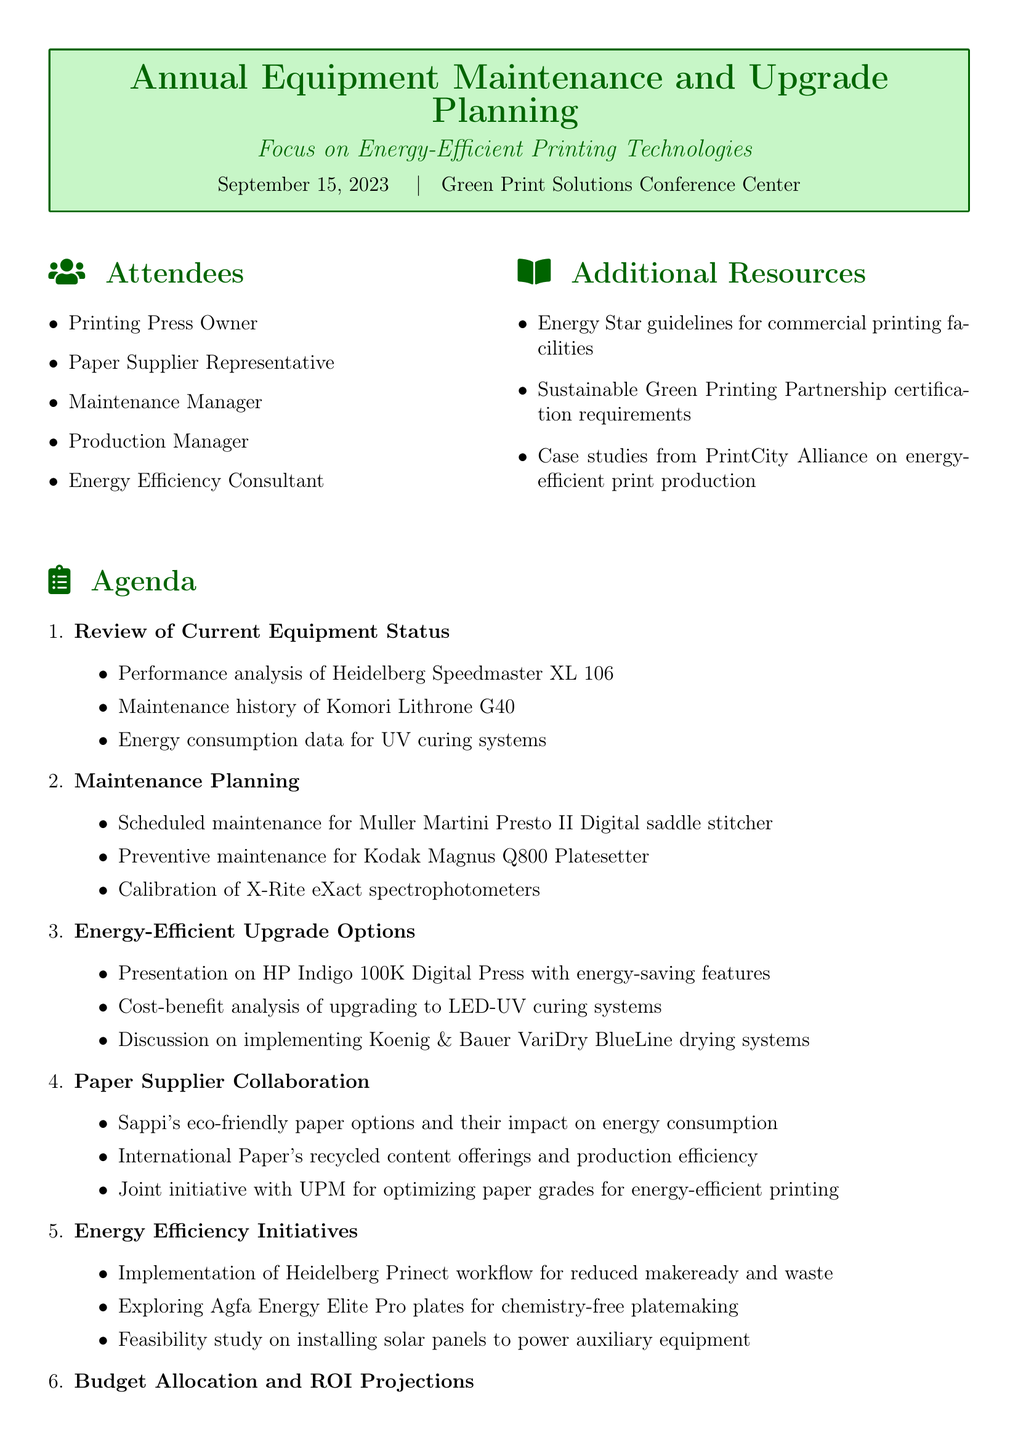What is the date of the session? The date of the session is provided in the document under the session details.
Answer: September 15, 2023 Who is the representative of the paper supplier? The attendees section lists all participants, including their roles.
Answer: Paper Supplier Representative What is one of the energy-efficient upgrade options presented? This is found in the energy-efficient upgrade options section of the agenda.
Answer: HP Indigo 100K Digital Press with energy-saving features How many attendees are listed in the document? The number of attendees is indicated in the attendees section.
Answer: Five What is the focus of the annual planning session? The focus is stated in the session title at the beginning of the document.
Answer: Energy-Efficient Printing Technologies What is one budget allocation topic discussed? This topic can be found in the budget allocation and ROI projections section.
Answer: Payback period calculations for new Komori H-UV L (LED) curing system Which system's maintenance history is reviewed? This information is available in the review of current equipment status section.
Answer: Komori Lithrone G40 What is the purpose of the action plan? The action plan is discussed towards the end of the agenda, focusing on maintenance and upgrades.
Answer: Prioritization of maintenance tasks and equipment upgrades 